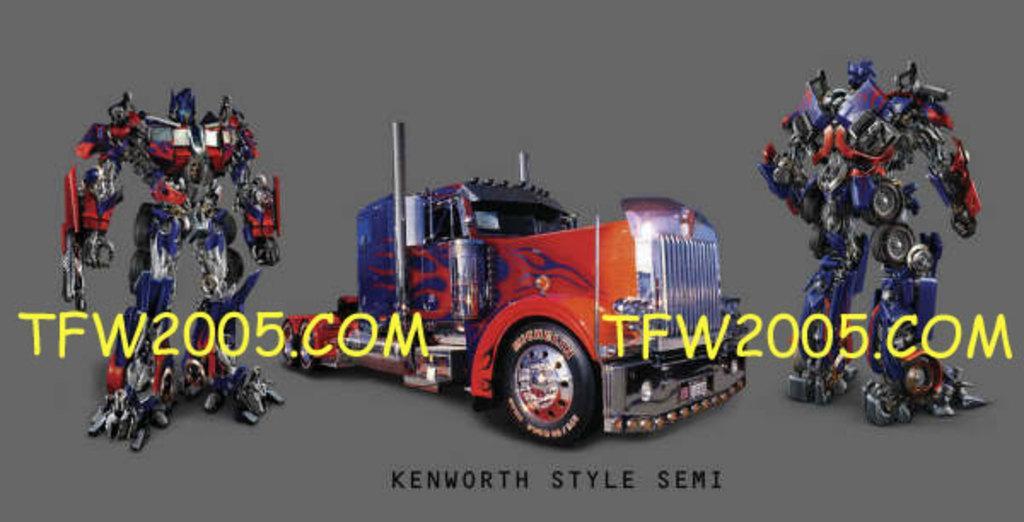Could you give a brief overview of what you see in this image? In this image I can see toys and in the middle I can see car toy , on the left and on the right side I can see retort toy and I can see text on the image. 